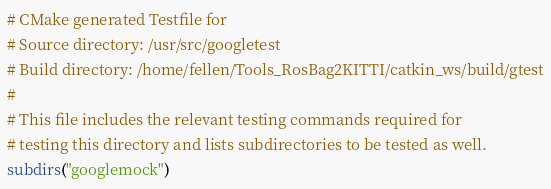<code> <loc_0><loc_0><loc_500><loc_500><_CMake_># CMake generated Testfile for 
# Source directory: /usr/src/googletest
# Build directory: /home/fellen/Tools_RosBag2KITTI/catkin_ws/build/gtest
# 
# This file includes the relevant testing commands required for 
# testing this directory and lists subdirectories to be tested as well.
subdirs("googlemock")
</code> 